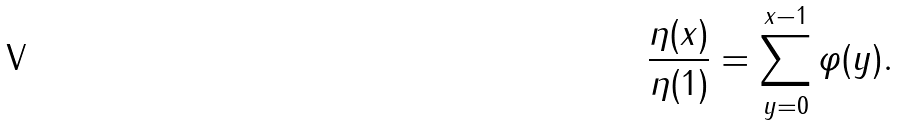Convert formula to latex. <formula><loc_0><loc_0><loc_500><loc_500>\frac { \eta ( x ) } { \eta ( 1 ) } = \sum _ { y = 0 } ^ { x - 1 } \varphi ( y ) .</formula> 